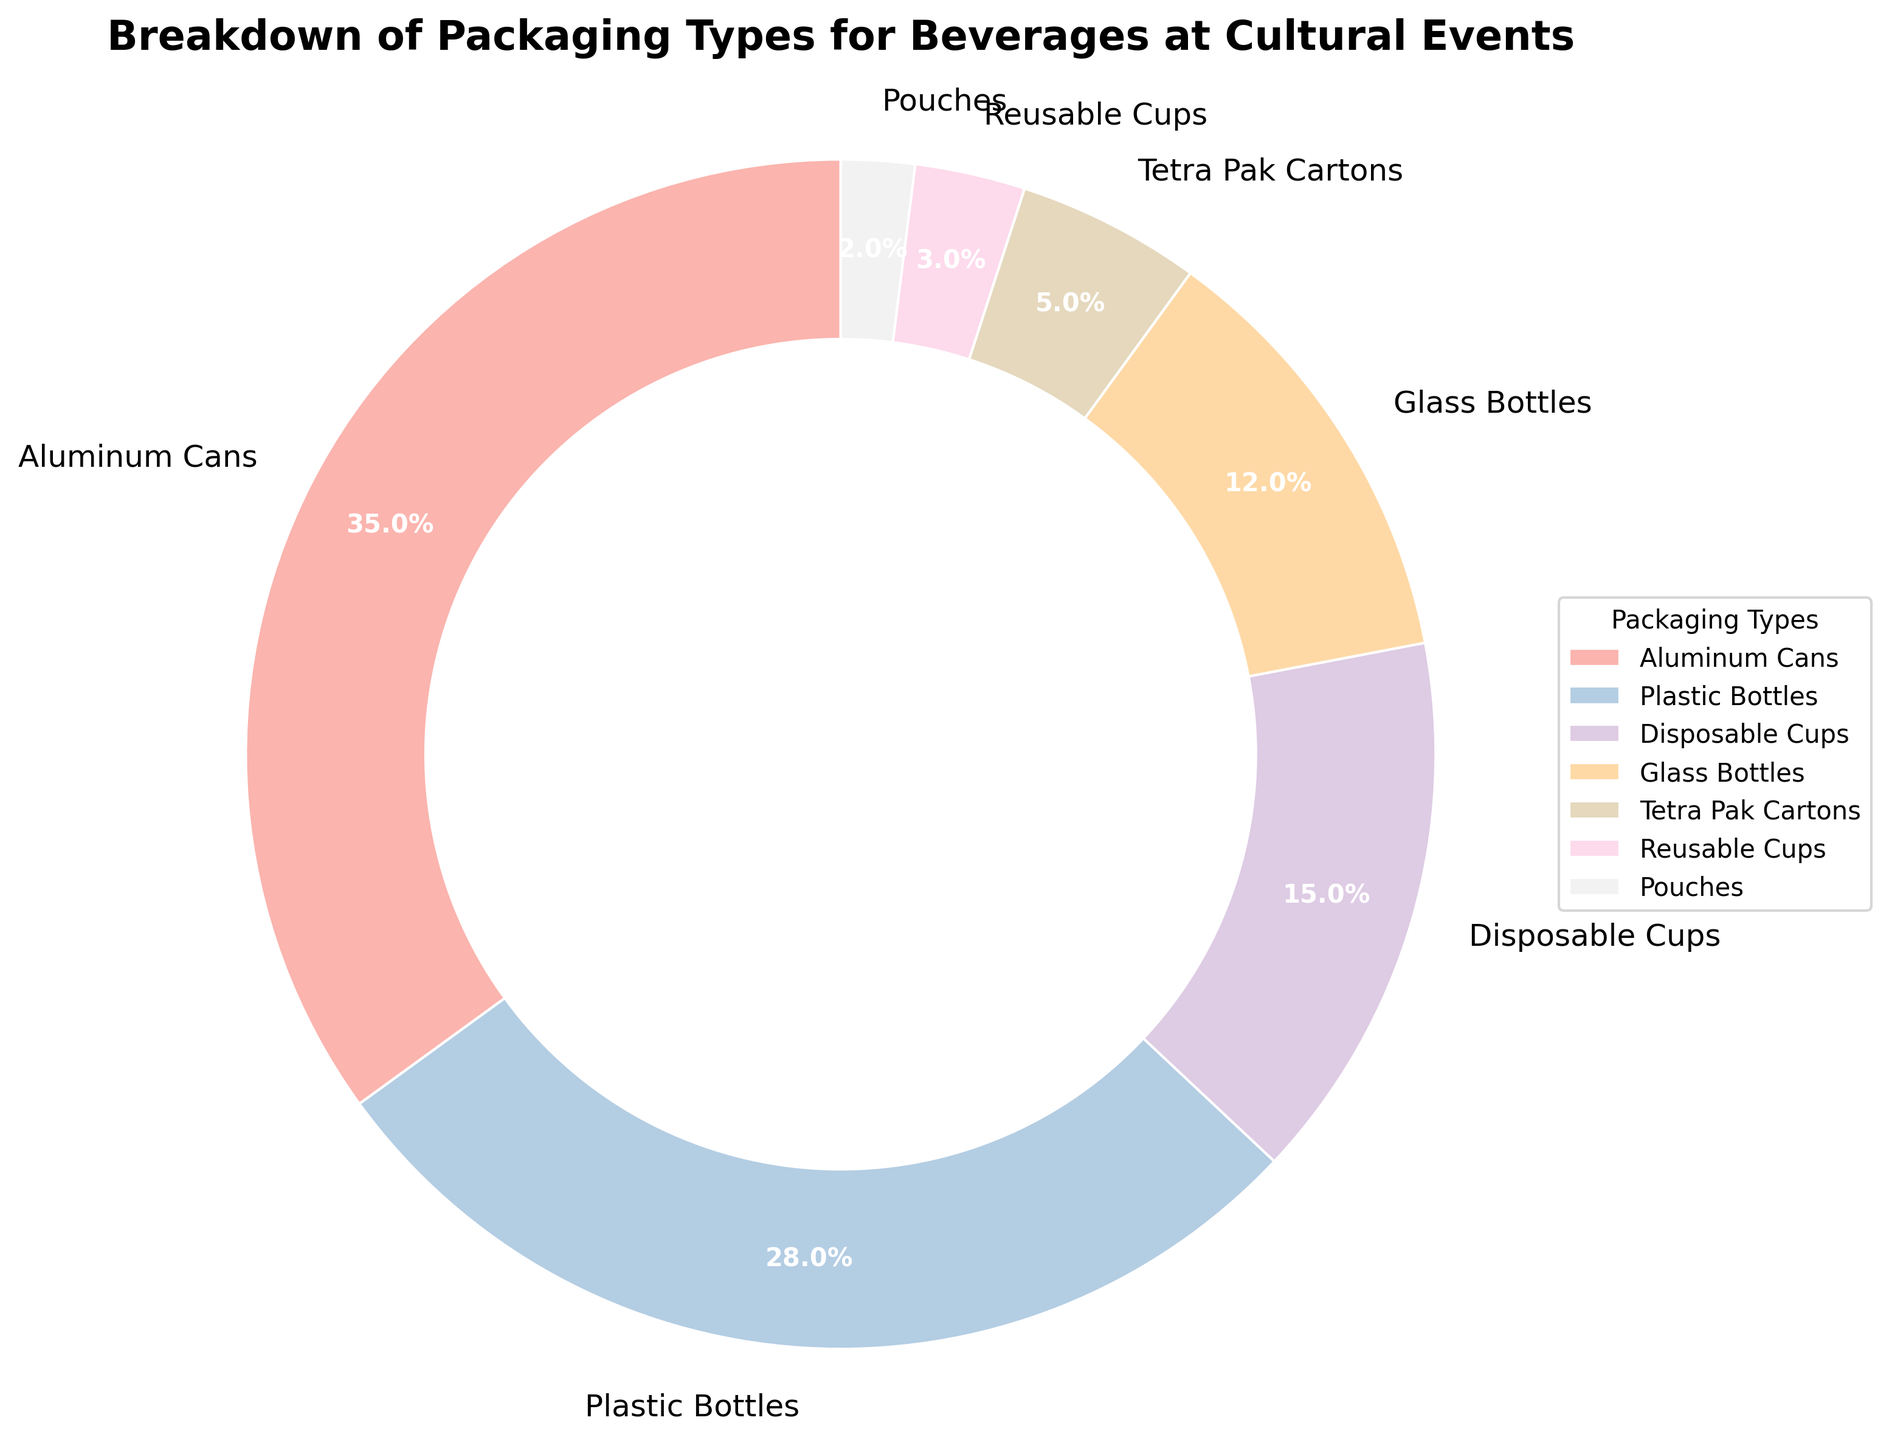Which packaging type is the most commonly used? The pie chart shows that the largest wedge, representing 35%, is Aluminum Cans.
Answer: Aluminum Cans Which packaging type accounts for 28% of the total? Referring to the pie chart, the wedge representing 28% is labeled Plastic Bottles.
Answer: Plastic Bottles What percentage is contributed by Disposable Cups and Tetra Pak Cartons combined? Disposable Cups contribute 15% and Tetra Pak Cartons contribute 5%. Adding these together gives 15% + 5% = 20%.
Answer: 20% How much more prevalent are Aluminum Cans than Glass Bottles? Aluminum Cans account for 35% and Glass Bottles account for 12%. The difference is 35% - 12% = 23%.
Answer: 23% What is the least common packaging type used at cultural events? The smallest wedge in the pie chart, representing 2%, is labeled Pouches.
Answer: Pouches What is the combined percentage of Plastic Bottles and Glass Bottles? Plastic Bottles contribute 28% and Glass Bottles account for 12%. Adding these together gives 28% + 12% = 40%.
Answer: 40% How does the percentage of Reusable Cups compare to Disposable Cups? Disposable Cups account for 15% while Reusable Cups contribute 3%. Disposable Cups are 15% - 3% = 12% more common than Reusable Cups.
Answer: 12% Which packaging types combined make up less than 10% of the total? Tetra Pak Cartons, Reusable Cups, and Pouches each account for 5%, 3%, and 2% respectively. Adding these gives 5% + 3% + 2% = 10%. Therefore, no individual combination of these types alone is below 10%.
Answer: None (individually less than 10%) What is the average percentage for all packaging types? Sum of all percentages: 35% (Aluminum Cans) + 28% (Plastic Bottles) + 15% (Disposable Cups) + 12% (Glass Bottles) + 5% (Tetra Pak Cartons) + 3% (Reusable Cups) + 2% (Pouches) = 100%. Dividing by the number of types (7): 100% / 7 ≈ 14.3%.
Answer: 14.3% 